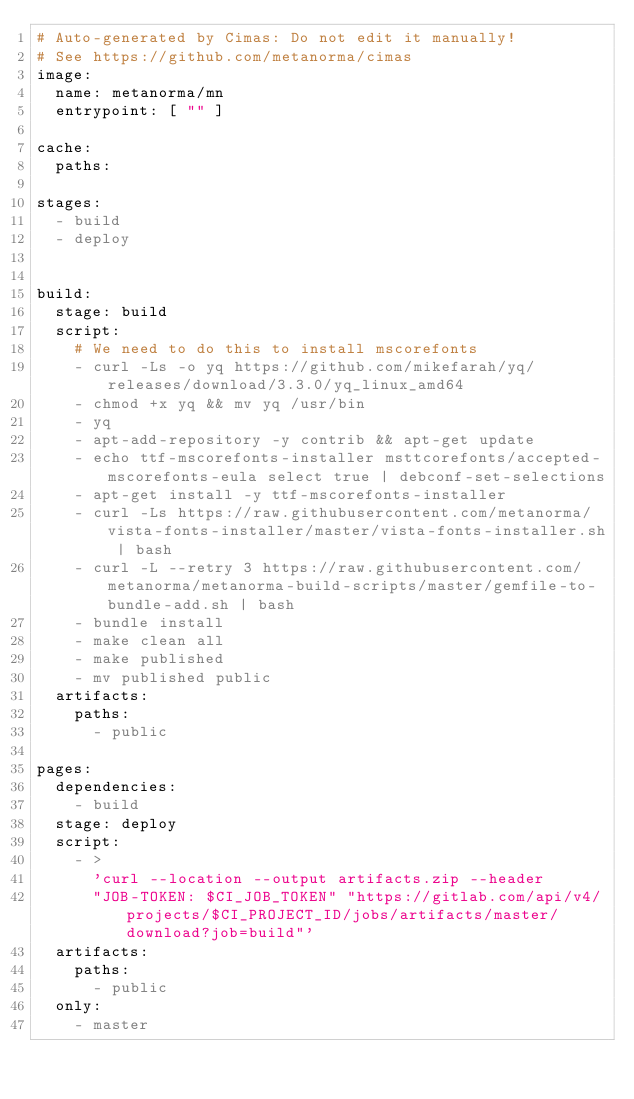Convert code to text. <code><loc_0><loc_0><loc_500><loc_500><_YAML_># Auto-generated by Cimas: Do not edit it manually!
# See https://github.com/metanorma/cimas
image:
  name: metanorma/mn
  entrypoint: [ "" ]

cache:
  paths:

stages:
  - build
  - deploy


build:
  stage: build
  script:
    # We need to do this to install mscorefonts
    - curl -Ls -o yq https://github.com/mikefarah/yq/releases/download/3.3.0/yq_linux_amd64
    - chmod +x yq && mv yq /usr/bin
    - yq
    - apt-add-repository -y contrib && apt-get update
    - echo ttf-mscorefonts-installer msttcorefonts/accepted-mscorefonts-eula select true | debconf-set-selections
    - apt-get install -y ttf-mscorefonts-installer
    - curl -Ls https://raw.githubusercontent.com/metanorma/vista-fonts-installer/master/vista-fonts-installer.sh | bash
    - curl -L --retry 3 https://raw.githubusercontent.com/metanorma/metanorma-build-scripts/master/gemfile-to-bundle-add.sh | bash
    - bundle install
    - make clean all
    - make published
    - mv published public
  artifacts:
    paths:
      - public

pages:
  dependencies:
    - build
  stage: deploy
  script:
    - >
      'curl --location --output artifacts.zip --header
      "JOB-TOKEN: $CI_JOB_TOKEN" "https://gitlab.com/api/v4/projects/$CI_PROJECT_ID/jobs/artifacts/master/download?job=build"'
  artifacts:
    paths:
      - public
  only:
    - master
</code> 